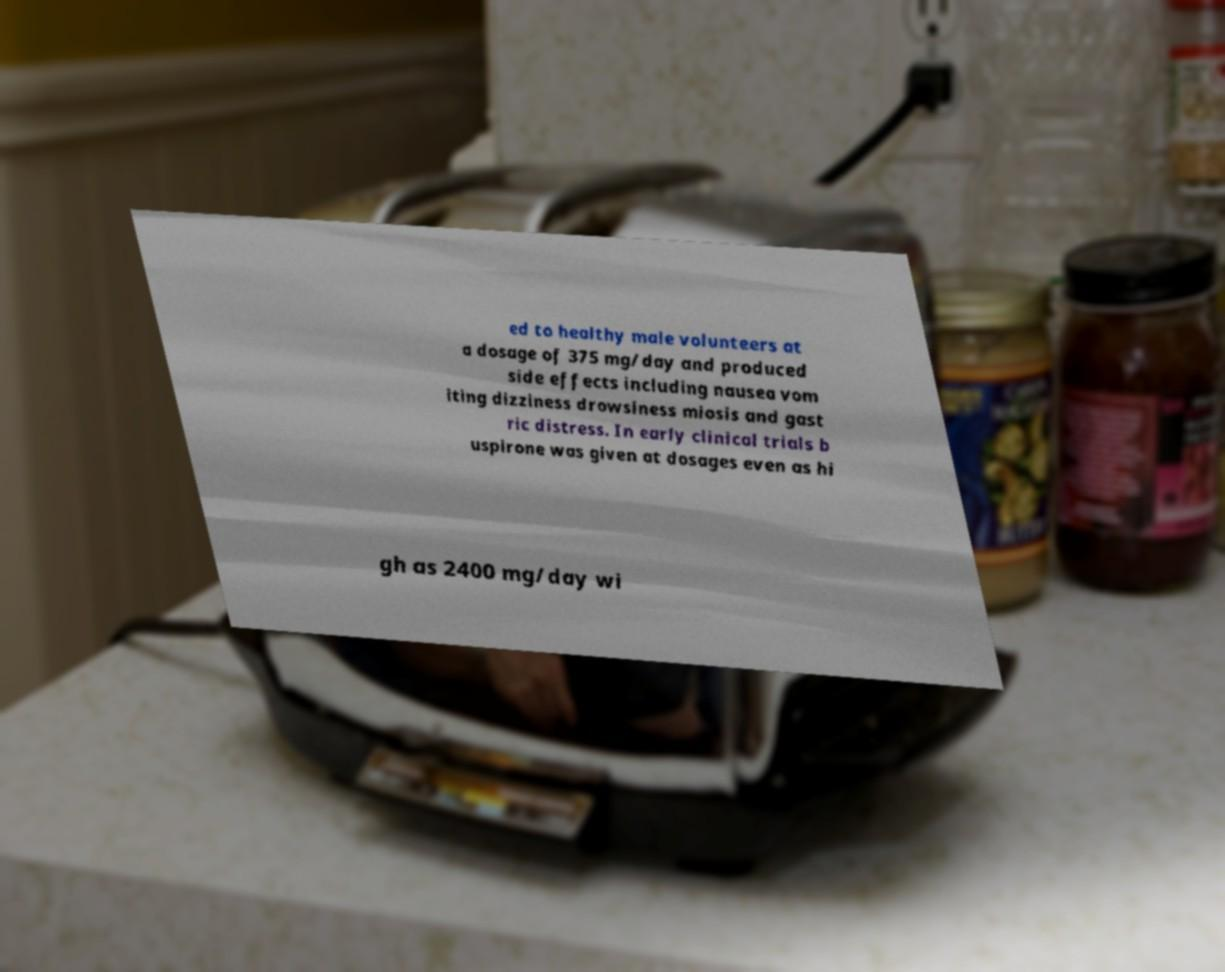For documentation purposes, I need the text within this image transcribed. Could you provide that? ed to healthy male volunteers at a dosage of 375 mg/day and produced side effects including nausea vom iting dizziness drowsiness miosis and gast ric distress. In early clinical trials b uspirone was given at dosages even as hi gh as 2400 mg/day wi 